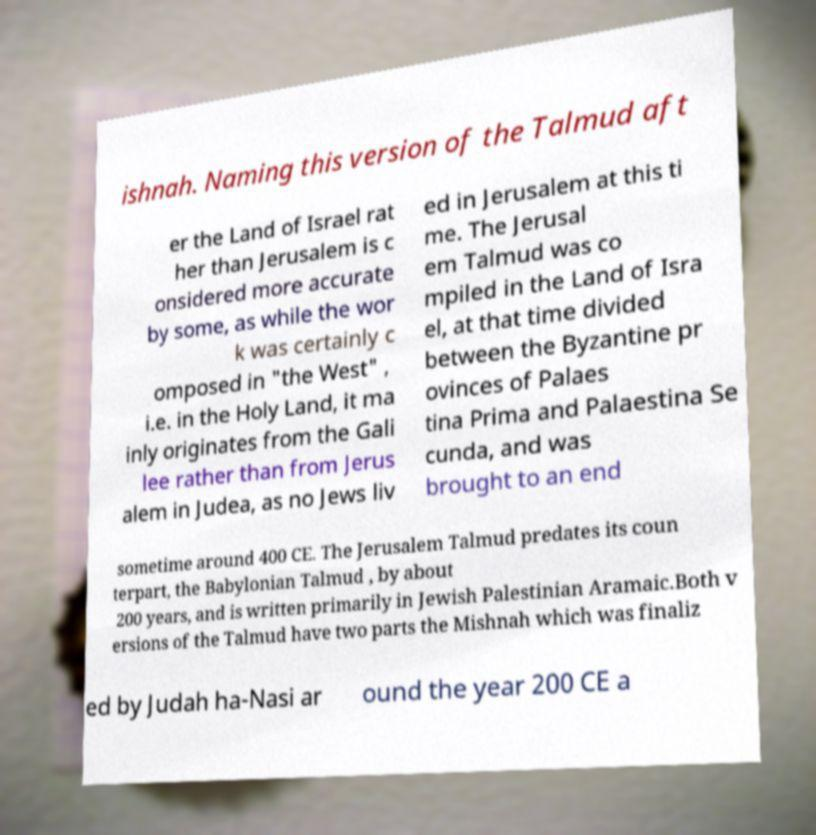Could you assist in decoding the text presented in this image and type it out clearly? ishnah. Naming this version of the Talmud aft er the Land of Israel rat her than Jerusalem is c onsidered more accurate by some, as while the wor k was certainly c omposed in "the West" , i.e. in the Holy Land, it ma inly originates from the Gali lee rather than from Jerus alem in Judea, as no Jews liv ed in Jerusalem at this ti me. The Jerusal em Talmud was co mpiled in the Land of Isra el, at that time divided between the Byzantine pr ovinces of Palaes tina Prima and Palaestina Se cunda, and was brought to an end sometime around 400 CE. The Jerusalem Talmud predates its coun terpart, the Babylonian Talmud , by about 200 years, and is written primarily in Jewish Palestinian Aramaic.Both v ersions of the Talmud have two parts the Mishnah which was finaliz ed by Judah ha-Nasi ar ound the year 200 CE a 